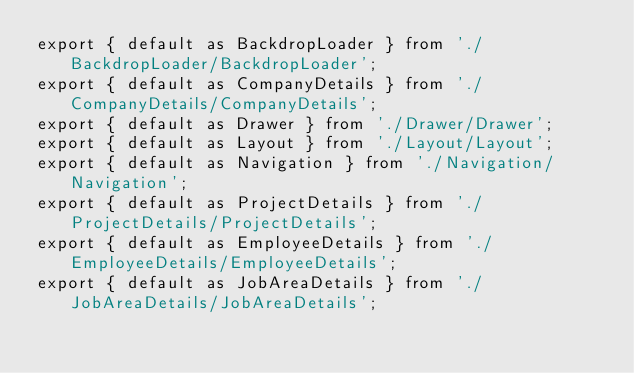Convert code to text. <code><loc_0><loc_0><loc_500><loc_500><_TypeScript_>export { default as BackdropLoader } from './BackdropLoader/BackdropLoader';
export { default as CompanyDetails } from './CompanyDetails/CompanyDetails';
export { default as Drawer } from './Drawer/Drawer';
export { default as Layout } from './Layout/Layout';
export { default as Navigation } from './Navigation/Navigation';
export { default as ProjectDetails } from './ProjectDetails/ProjectDetails';
export { default as EmployeeDetails } from './EmployeeDetails/EmployeeDetails';
export { default as JobAreaDetails } from './JobAreaDetails/JobAreaDetails';
</code> 